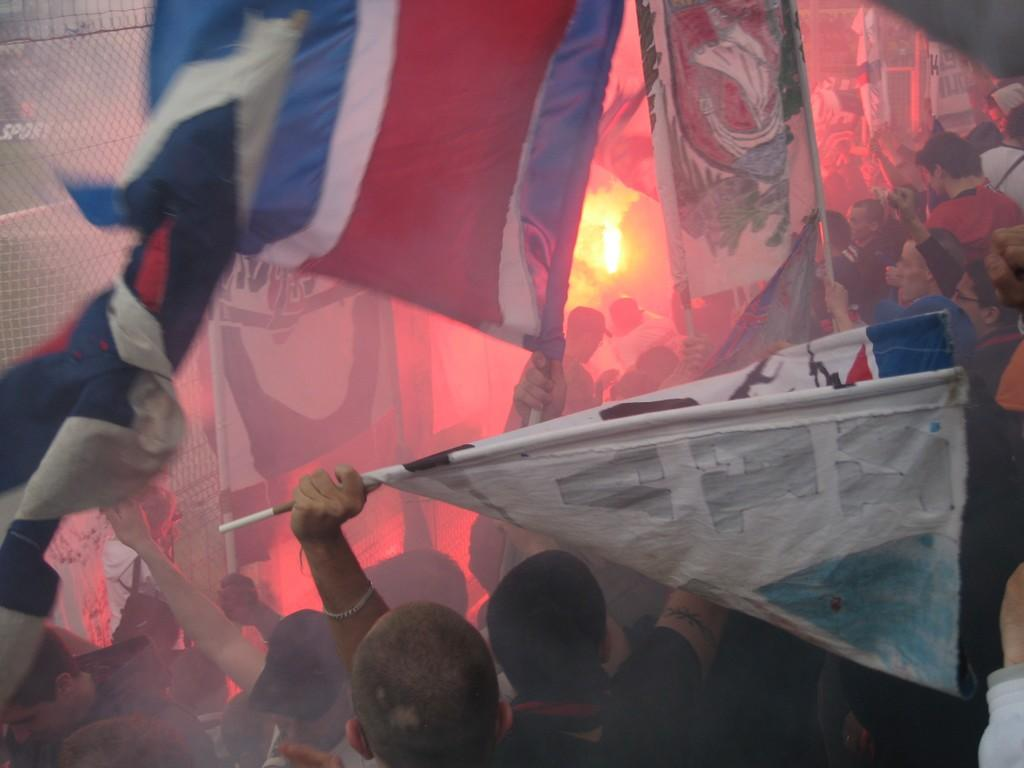How many people are present in the image? There are many people in the image. What are some people doing in the image? Some people are holding flags. Can you describe any objects in the image besides the people? Yes, there is a lamp in the image. What is located on the left side of the image? There is a fencing at the left side of the image. How many potatoes can be seen in the image? There are no potatoes present in the image. What type of quiver is being used by the people holding flags? There is no quiver present in the image, as the people holding flags are not using any such item. 